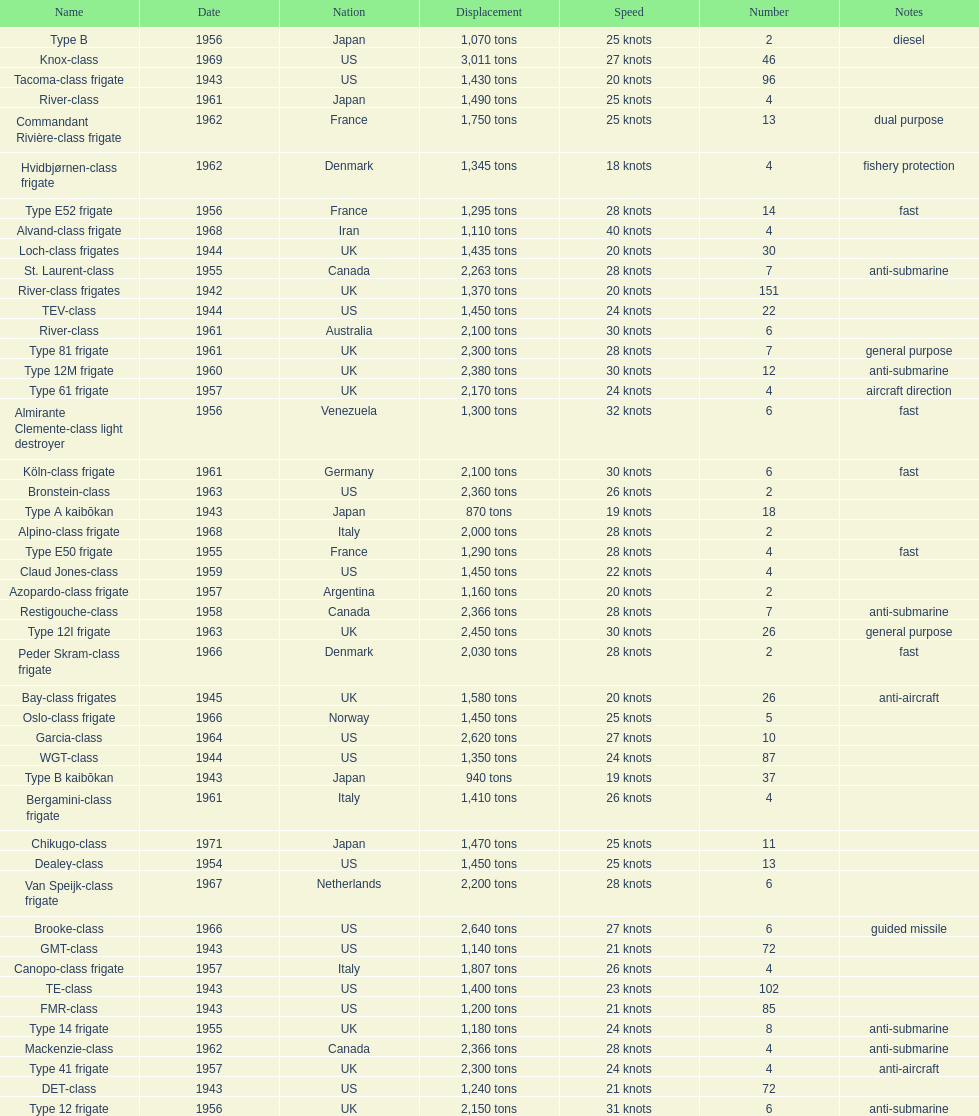How many tons of displacement does type b have? 940 tons. 